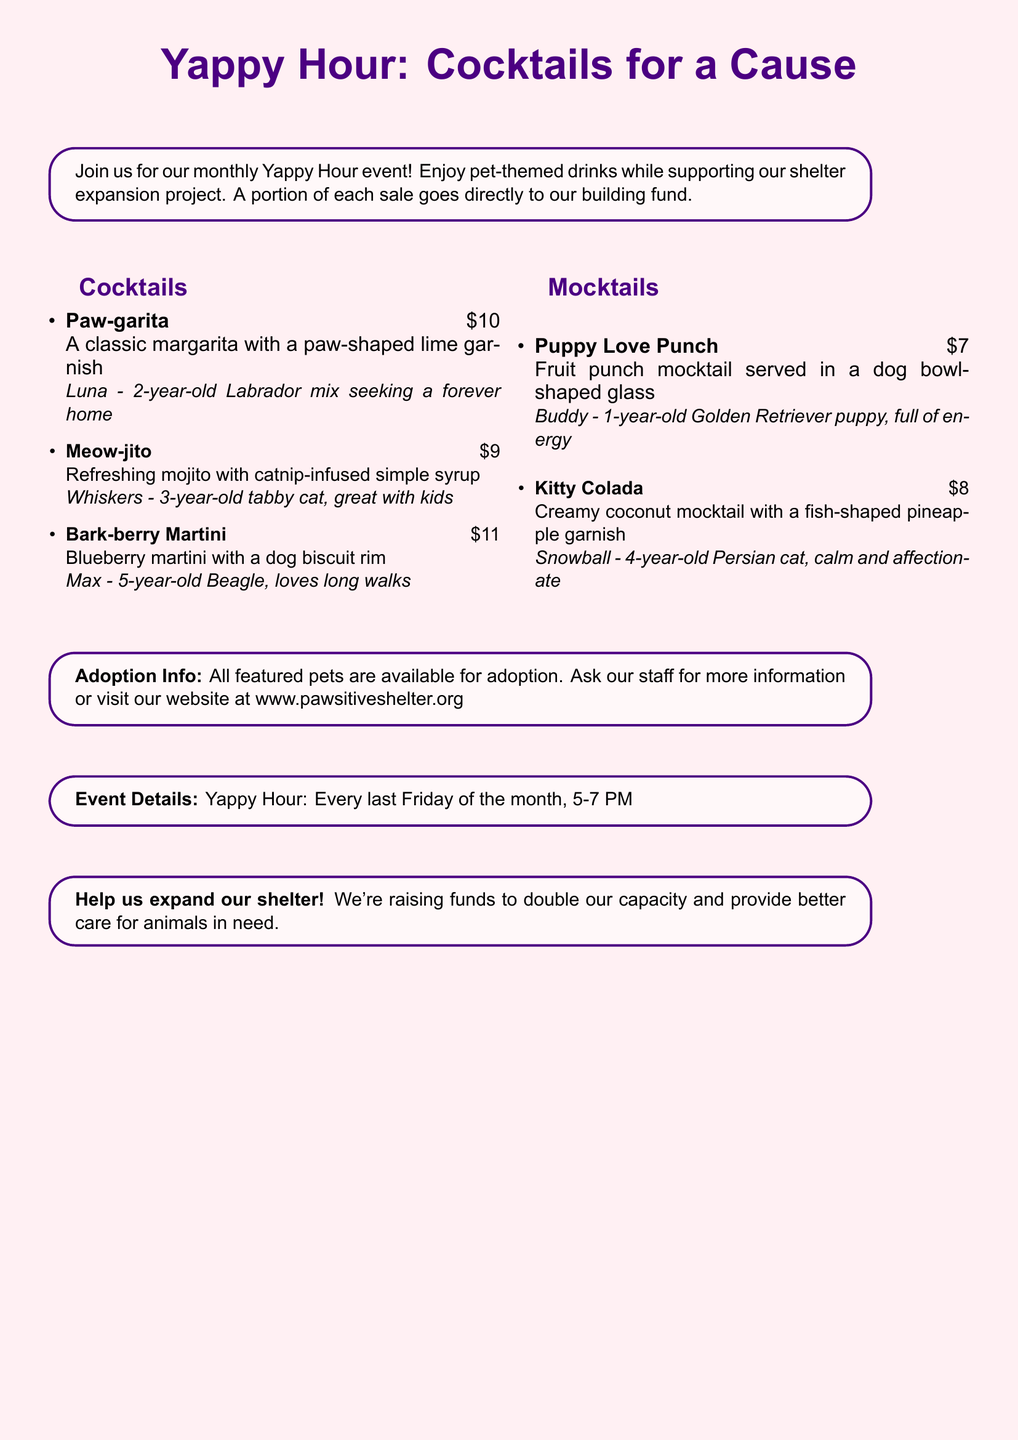What is the theme of the drinks offered? The theme of the drinks is pet-themed cocktails and mocktails.
Answer: Pet-themed cocktails and mocktails How much does the Paw-garita cost? The cost of the Paw-garita is listed on the menu.
Answer: $10 What animal is Luna? Luna is described in the context of the Paw-garita.
Answer: 2-year-old Labrador mix What is the name of the event? The title of the event as mentioned at the start of the document.
Answer: Yappy Hour How many mocktails are listed on the menu? The total number of mocktails can be counted from the document.
Answer: 2 What time does Yappy Hour start? The start time is provided in the event details section.
Answer: 5 PM Which cocktail has a dog biscuit rim? This requires identification of the specific drink from the menu.
Answer: Bark-berry Martini How often does Yappy Hour occur? The frequency is given in the event details.
Answer: Every last Friday of the month 